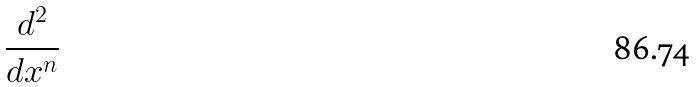<formula> <loc_0><loc_0><loc_500><loc_500>\frac { d ^ { 2 } } { d x ^ { n } }</formula> 